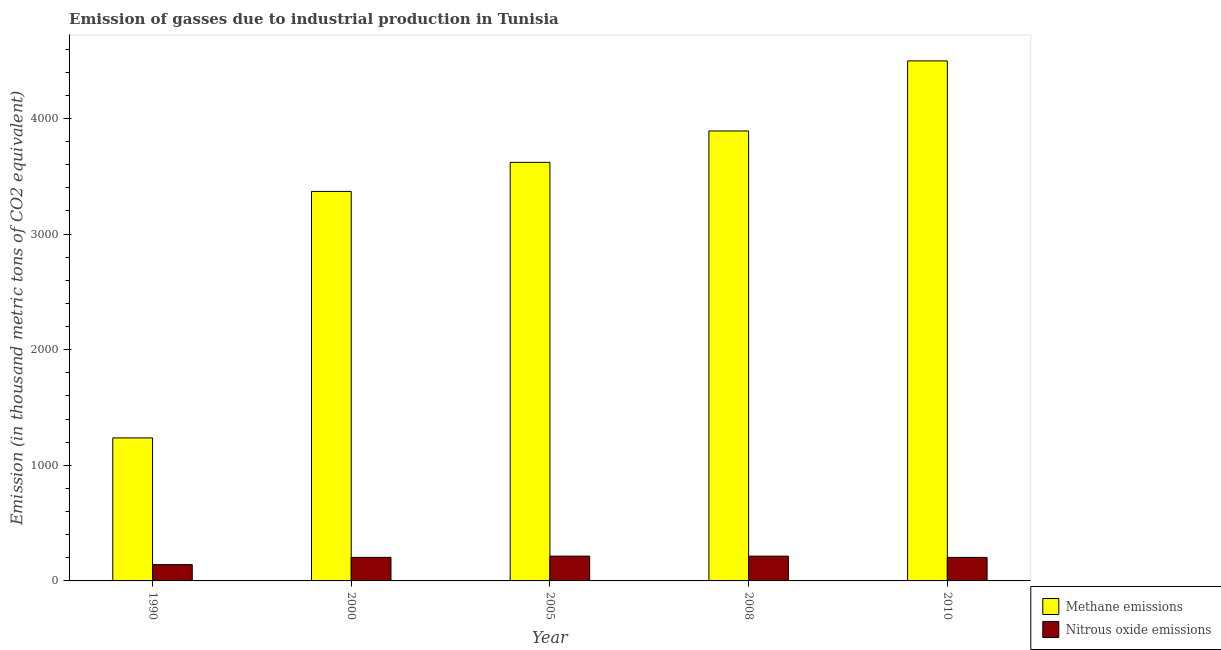Are the number of bars on each tick of the X-axis equal?
Provide a succinct answer. Yes. How many bars are there on the 1st tick from the right?
Provide a short and direct response. 2. In how many cases, is the number of bars for a given year not equal to the number of legend labels?
Offer a very short reply. 0. What is the amount of methane emissions in 2000?
Offer a terse response. 3368.9. Across all years, what is the maximum amount of nitrous oxide emissions?
Make the answer very short. 214.5. Across all years, what is the minimum amount of nitrous oxide emissions?
Make the answer very short. 141. What is the total amount of nitrous oxide emissions in the graph?
Ensure brevity in your answer.  976.8. What is the difference between the amount of nitrous oxide emissions in 1990 and that in 2008?
Your answer should be compact. -73.3. What is the difference between the amount of nitrous oxide emissions in 1990 and the amount of methane emissions in 2000?
Offer a terse response. -62.7. What is the average amount of nitrous oxide emissions per year?
Keep it short and to the point. 195.36. In the year 2008, what is the difference between the amount of methane emissions and amount of nitrous oxide emissions?
Provide a succinct answer. 0. In how many years, is the amount of methane emissions greater than 1200 thousand metric tons?
Make the answer very short. 5. What is the ratio of the amount of methane emissions in 1990 to that in 2005?
Provide a short and direct response. 0.34. Is the difference between the amount of nitrous oxide emissions in 1990 and 2010 greater than the difference between the amount of methane emissions in 1990 and 2010?
Make the answer very short. No. What is the difference between the highest and the second highest amount of nitrous oxide emissions?
Ensure brevity in your answer.  0.2. What is the difference between the highest and the lowest amount of nitrous oxide emissions?
Provide a short and direct response. 73.5. In how many years, is the amount of methane emissions greater than the average amount of methane emissions taken over all years?
Your answer should be very brief. 4. What does the 2nd bar from the left in 2005 represents?
Give a very brief answer. Nitrous oxide emissions. What does the 2nd bar from the right in 2010 represents?
Provide a short and direct response. Methane emissions. How many years are there in the graph?
Offer a very short reply. 5. What is the difference between two consecutive major ticks on the Y-axis?
Keep it short and to the point. 1000. Does the graph contain any zero values?
Make the answer very short. No. Does the graph contain grids?
Offer a very short reply. No. Where does the legend appear in the graph?
Make the answer very short. Bottom right. How many legend labels are there?
Provide a succinct answer. 2. How are the legend labels stacked?
Provide a short and direct response. Vertical. What is the title of the graph?
Make the answer very short. Emission of gasses due to industrial production in Tunisia. What is the label or title of the X-axis?
Make the answer very short. Year. What is the label or title of the Y-axis?
Your answer should be very brief. Emission (in thousand metric tons of CO2 equivalent). What is the Emission (in thousand metric tons of CO2 equivalent) of Methane emissions in 1990?
Your answer should be compact. 1237. What is the Emission (in thousand metric tons of CO2 equivalent) of Nitrous oxide emissions in 1990?
Your answer should be very brief. 141. What is the Emission (in thousand metric tons of CO2 equivalent) in Methane emissions in 2000?
Offer a very short reply. 3368.9. What is the Emission (in thousand metric tons of CO2 equivalent) of Nitrous oxide emissions in 2000?
Your answer should be compact. 203.7. What is the Emission (in thousand metric tons of CO2 equivalent) of Methane emissions in 2005?
Provide a short and direct response. 3620.1. What is the Emission (in thousand metric tons of CO2 equivalent) in Nitrous oxide emissions in 2005?
Your answer should be very brief. 214.5. What is the Emission (in thousand metric tons of CO2 equivalent) in Methane emissions in 2008?
Give a very brief answer. 3891.6. What is the Emission (in thousand metric tons of CO2 equivalent) in Nitrous oxide emissions in 2008?
Make the answer very short. 214.3. What is the Emission (in thousand metric tons of CO2 equivalent) in Methane emissions in 2010?
Ensure brevity in your answer.  4497.8. What is the Emission (in thousand metric tons of CO2 equivalent) in Nitrous oxide emissions in 2010?
Keep it short and to the point. 203.3. Across all years, what is the maximum Emission (in thousand metric tons of CO2 equivalent) in Methane emissions?
Offer a terse response. 4497.8. Across all years, what is the maximum Emission (in thousand metric tons of CO2 equivalent) in Nitrous oxide emissions?
Provide a short and direct response. 214.5. Across all years, what is the minimum Emission (in thousand metric tons of CO2 equivalent) of Methane emissions?
Offer a terse response. 1237. Across all years, what is the minimum Emission (in thousand metric tons of CO2 equivalent) of Nitrous oxide emissions?
Provide a succinct answer. 141. What is the total Emission (in thousand metric tons of CO2 equivalent) in Methane emissions in the graph?
Ensure brevity in your answer.  1.66e+04. What is the total Emission (in thousand metric tons of CO2 equivalent) in Nitrous oxide emissions in the graph?
Provide a succinct answer. 976.8. What is the difference between the Emission (in thousand metric tons of CO2 equivalent) of Methane emissions in 1990 and that in 2000?
Keep it short and to the point. -2131.9. What is the difference between the Emission (in thousand metric tons of CO2 equivalent) of Nitrous oxide emissions in 1990 and that in 2000?
Offer a very short reply. -62.7. What is the difference between the Emission (in thousand metric tons of CO2 equivalent) in Methane emissions in 1990 and that in 2005?
Offer a very short reply. -2383.1. What is the difference between the Emission (in thousand metric tons of CO2 equivalent) in Nitrous oxide emissions in 1990 and that in 2005?
Give a very brief answer. -73.5. What is the difference between the Emission (in thousand metric tons of CO2 equivalent) of Methane emissions in 1990 and that in 2008?
Your answer should be very brief. -2654.6. What is the difference between the Emission (in thousand metric tons of CO2 equivalent) in Nitrous oxide emissions in 1990 and that in 2008?
Offer a very short reply. -73.3. What is the difference between the Emission (in thousand metric tons of CO2 equivalent) of Methane emissions in 1990 and that in 2010?
Offer a very short reply. -3260.8. What is the difference between the Emission (in thousand metric tons of CO2 equivalent) in Nitrous oxide emissions in 1990 and that in 2010?
Make the answer very short. -62.3. What is the difference between the Emission (in thousand metric tons of CO2 equivalent) of Methane emissions in 2000 and that in 2005?
Offer a terse response. -251.2. What is the difference between the Emission (in thousand metric tons of CO2 equivalent) in Methane emissions in 2000 and that in 2008?
Provide a succinct answer. -522.7. What is the difference between the Emission (in thousand metric tons of CO2 equivalent) in Nitrous oxide emissions in 2000 and that in 2008?
Provide a succinct answer. -10.6. What is the difference between the Emission (in thousand metric tons of CO2 equivalent) of Methane emissions in 2000 and that in 2010?
Keep it short and to the point. -1128.9. What is the difference between the Emission (in thousand metric tons of CO2 equivalent) of Methane emissions in 2005 and that in 2008?
Your answer should be very brief. -271.5. What is the difference between the Emission (in thousand metric tons of CO2 equivalent) in Methane emissions in 2005 and that in 2010?
Make the answer very short. -877.7. What is the difference between the Emission (in thousand metric tons of CO2 equivalent) in Methane emissions in 2008 and that in 2010?
Your answer should be compact. -606.2. What is the difference between the Emission (in thousand metric tons of CO2 equivalent) in Nitrous oxide emissions in 2008 and that in 2010?
Your answer should be very brief. 11. What is the difference between the Emission (in thousand metric tons of CO2 equivalent) of Methane emissions in 1990 and the Emission (in thousand metric tons of CO2 equivalent) of Nitrous oxide emissions in 2000?
Provide a short and direct response. 1033.3. What is the difference between the Emission (in thousand metric tons of CO2 equivalent) in Methane emissions in 1990 and the Emission (in thousand metric tons of CO2 equivalent) in Nitrous oxide emissions in 2005?
Provide a succinct answer. 1022.5. What is the difference between the Emission (in thousand metric tons of CO2 equivalent) of Methane emissions in 1990 and the Emission (in thousand metric tons of CO2 equivalent) of Nitrous oxide emissions in 2008?
Your answer should be very brief. 1022.7. What is the difference between the Emission (in thousand metric tons of CO2 equivalent) in Methane emissions in 1990 and the Emission (in thousand metric tons of CO2 equivalent) in Nitrous oxide emissions in 2010?
Offer a terse response. 1033.7. What is the difference between the Emission (in thousand metric tons of CO2 equivalent) in Methane emissions in 2000 and the Emission (in thousand metric tons of CO2 equivalent) in Nitrous oxide emissions in 2005?
Your response must be concise. 3154.4. What is the difference between the Emission (in thousand metric tons of CO2 equivalent) in Methane emissions in 2000 and the Emission (in thousand metric tons of CO2 equivalent) in Nitrous oxide emissions in 2008?
Give a very brief answer. 3154.6. What is the difference between the Emission (in thousand metric tons of CO2 equivalent) in Methane emissions in 2000 and the Emission (in thousand metric tons of CO2 equivalent) in Nitrous oxide emissions in 2010?
Give a very brief answer. 3165.6. What is the difference between the Emission (in thousand metric tons of CO2 equivalent) of Methane emissions in 2005 and the Emission (in thousand metric tons of CO2 equivalent) of Nitrous oxide emissions in 2008?
Your response must be concise. 3405.8. What is the difference between the Emission (in thousand metric tons of CO2 equivalent) in Methane emissions in 2005 and the Emission (in thousand metric tons of CO2 equivalent) in Nitrous oxide emissions in 2010?
Keep it short and to the point. 3416.8. What is the difference between the Emission (in thousand metric tons of CO2 equivalent) of Methane emissions in 2008 and the Emission (in thousand metric tons of CO2 equivalent) of Nitrous oxide emissions in 2010?
Your answer should be very brief. 3688.3. What is the average Emission (in thousand metric tons of CO2 equivalent) in Methane emissions per year?
Your answer should be compact. 3323.08. What is the average Emission (in thousand metric tons of CO2 equivalent) of Nitrous oxide emissions per year?
Ensure brevity in your answer.  195.36. In the year 1990, what is the difference between the Emission (in thousand metric tons of CO2 equivalent) of Methane emissions and Emission (in thousand metric tons of CO2 equivalent) of Nitrous oxide emissions?
Offer a very short reply. 1096. In the year 2000, what is the difference between the Emission (in thousand metric tons of CO2 equivalent) of Methane emissions and Emission (in thousand metric tons of CO2 equivalent) of Nitrous oxide emissions?
Make the answer very short. 3165.2. In the year 2005, what is the difference between the Emission (in thousand metric tons of CO2 equivalent) in Methane emissions and Emission (in thousand metric tons of CO2 equivalent) in Nitrous oxide emissions?
Offer a very short reply. 3405.6. In the year 2008, what is the difference between the Emission (in thousand metric tons of CO2 equivalent) in Methane emissions and Emission (in thousand metric tons of CO2 equivalent) in Nitrous oxide emissions?
Keep it short and to the point. 3677.3. In the year 2010, what is the difference between the Emission (in thousand metric tons of CO2 equivalent) of Methane emissions and Emission (in thousand metric tons of CO2 equivalent) of Nitrous oxide emissions?
Your answer should be compact. 4294.5. What is the ratio of the Emission (in thousand metric tons of CO2 equivalent) in Methane emissions in 1990 to that in 2000?
Make the answer very short. 0.37. What is the ratio of the Emission (in thousand metric tons of CO2 equivalent) in Nitrous oxide emissions in 1990 to that in 2000?
Your response must be concise. 0.69. What is the ratio of the Emission (in thousand metric tons of CO2 equivalent) in Methane emissions in 1990 to that in 2005?
Provide a succinct answer. 0.34. What is the ratio of the Emission (in thousand metric tons of CO2 equivalent) in Nitrous oxide emissions in 1990 to that in 2005?
Keep it short and to the point. 0.66. What is the ratio of the Emission (in thousand metric tons of CO2 equivalent) of Methane emissions in 1990 to that in 2008?
Offer a very short reply. 0.32. What is the ratio of the Emission (in thousand metric tons of CO2 equivalent) in Nitrous oxide emissions in 1990 to that in 2008?
Make the answer very short. 0.66. What is the ratio of the Emission (in thousand metric tons of CO2 equivalent) in Methane emissions in 1990 to that in 2010?
Your answer should be compact. 0.28. What is the ratio of the Emission (in thousand metric tons of CO2 equivalent) of Nitrous oxide emissions in 1990 to that in 2010?
Provide a succinct answer. 0.69. What is the ratio of the Emission (in thousand metric tons of CO2 equivalent) of Methane emissions in 2000 to that in 2005?
Offer a very short reply. 0.93. What is the ratio of the Emission (in thousand metric tons of CO2 equivalent) in Nitrous oxide emissions in 2000 to that in 2005?
Ensure brevity in your answer.  0.95. What is the ratio of the Emission (in thousand metric tons of CO2 equivalent) in Methane emissions in 2000 to that in 2008?
Make the answer very short. 0.87. What is the ratio of the Emission (in thousand metric tons of CO2 equivalent) of Nitrous oxide emissions in 2000 to that in 2008?
Your answer should be very brief. 0.95. What is the ratio of the Emission (in thousand metric tons of CO2 equivalent) in Methane emissions in 2000 to that in 2010?
Keep it short and to the point. 0.75. What is the ratio of the Emission (in thousand metric tons of CO2 equivalent) in Methane emissions in 2005 to that in 2008?
Ensure brevity in your answer.  0.93. What is the ratio of the Emission (in thousand metric tons of CO2 equivalent) in Nitrous oxide emissions in 2005 to that in 2008?
Offer a very short reply. 1. What is the ratio of the Emission (in thousand metric tons of CO2 equivalent) of Methane emissions in 2005 to that in 2010?
Your response must be concise. 0.8. What is the ratio of the Emission (in thousand metric tons of CO2 equivalent) in Nitrous oxide emissions in 2005 to that in 2010?
Make the answer very short. 1.06. What is the ratio of the Emission (in thousand metric tons of CO2 equivalent) in Methane emissions in 2008 to that in 2010?
Offer a terse response. 0.87. What is the ratio of the Emission (in thousand metric tons of CO2 equivalent) in Nitrous oxide emissions in 2008 to that in 2010?
Ensure brevity in your answer.  1.05. What is the difference between the highest and the second highest Emission (in thousand metric tons of CO2 equivalent) in Methane emissions?
Your answer should be very brief. 606.2. What is the difference between the highest and the lowest Emission (in thousand metric tons of CO2 equivalent) of Methane emissions?
Offer a very short reply. 3260.8. What is the difference between the highest and the lowest Emission (in thousand metric tons of CO2 equivalent) in Nitrous oxide emissions?
Offer a terse response. 73.5. 